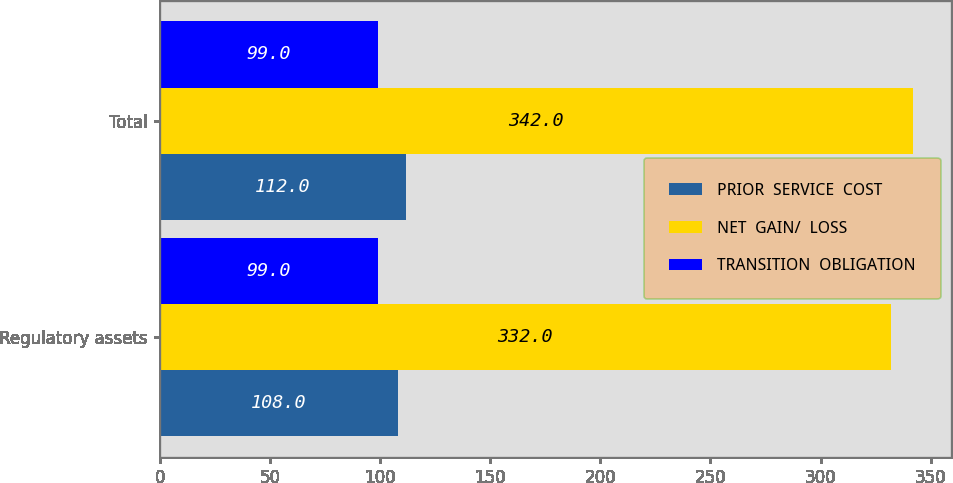Convert chart to OTSL. <chart><loc_0><loc_0><loc_500><loc_500><stacked_bar_chart><ecel><fcel>Regulatory assets<fcel>Total<nl><fcel>PRIOR  SERVICE  COST<fcel>108<fcel>112<nl><fcel>NET  GAIN/  LOSS<fcel>332<fcel>342<nl><fcel>TRANSITION  OBLIGATION<fcel>99<fcel>99<nl></chart> 